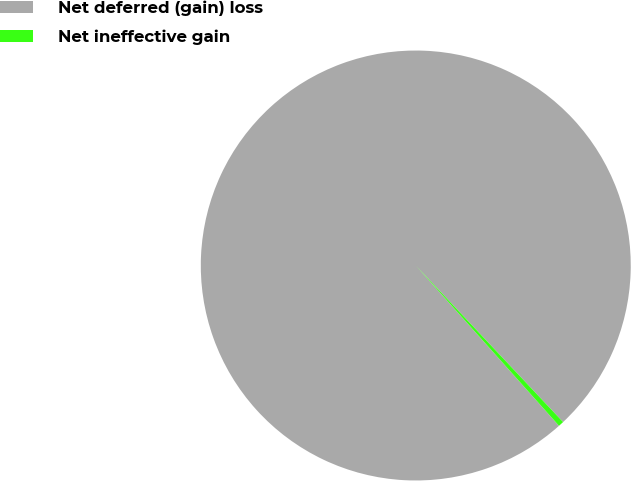<chart> <loc_0><loc_0><loc_500><loc_500><pie_chart><fcel>Net deferred (gain) loss<fcel>Net ineffective gain<nl><fcel>99.59%<fcel>0.41%<nl></chart> 